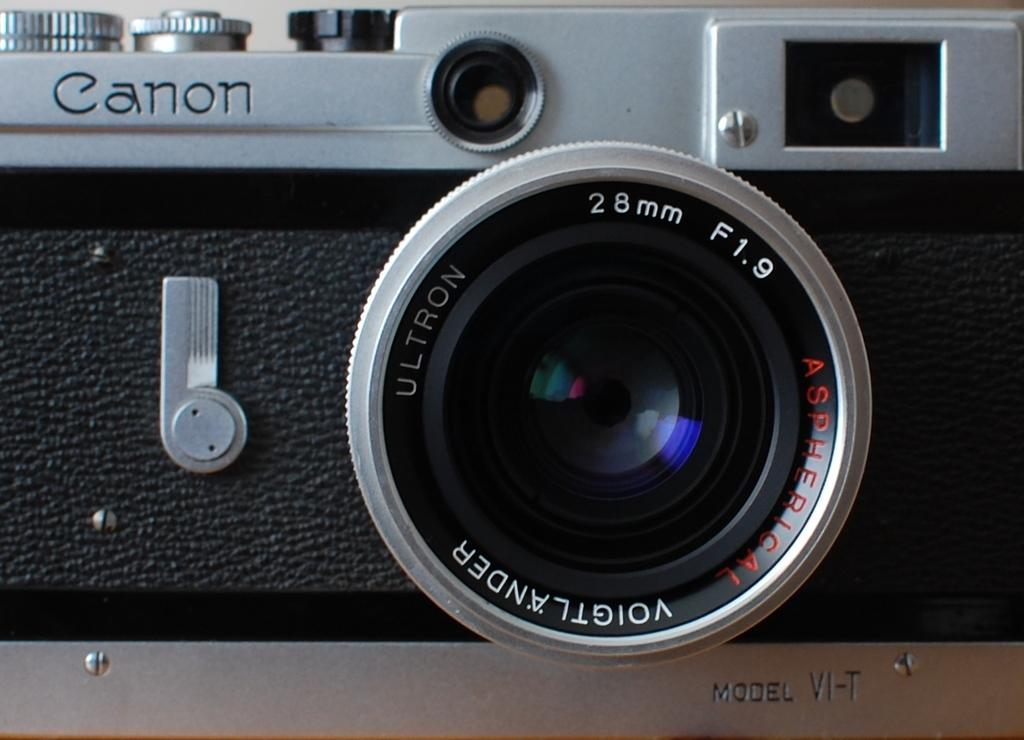What object is the main subject of the image? There is a camera in the image. Can you describe any additional features of the camera? There is writing on the camera. Is there a hill covered in soap in the image? No, there is no hill or soap present in the image; it features a camera with writing on it. 